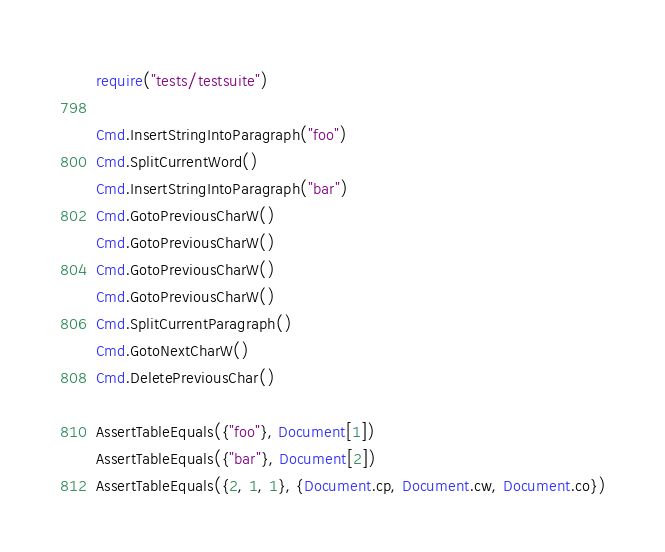Convert code to text. <code><loc_0><loc_0><loc_500><loc_500><_Lua_>require("tests/testsuite")

Cmd.InsertStringIntoParagraph("foo")
Cmd.SplitCurrentWord()
Cmd.InsertStringIntoParagraph("bar")
Cmd.GotoPreviousCharW()
Cmd.GotoPreviousCharW()
Cmd.GotoPreviousCharW()
Cmd.GotoPreviousCharW()
Cmd.SplitCurrentParagraph()
Cmd.GotoNextCharW()
Cmd.DeletePreviousChar()

AssertTableEquals({"foo"}, Document[1])
AssertTableEquals({"bar"}, Document[2])
AssertTableEquals({2, 1, 1}, {Document.cp, Document.cw, Document.co})

</code> 